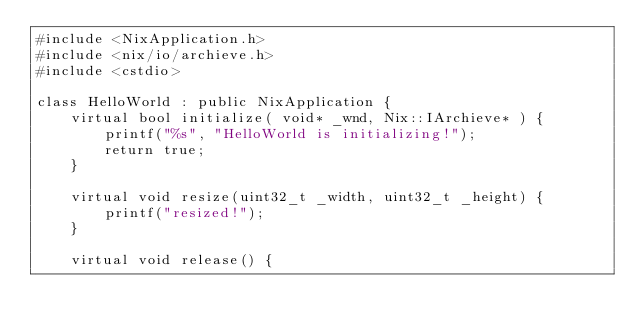<code> <loc_0><loc_0><loc_500><loc_500><_C++_>#include <NixApplication.h>
#include <nix/io/archieve.h>
#include <cstdio>

class HelloWorld : public NixApplication {
	virtual bool initialize( void* _wnd, Nix::IArchieve* ) {
        printf("%s", "HelloWorld is initializing!");
		return true;
    }
    
	virtual void resize(uint32_t _width, uint32_t _height) {
        printf("resized!");
    }

	virtual void release() {</code> 